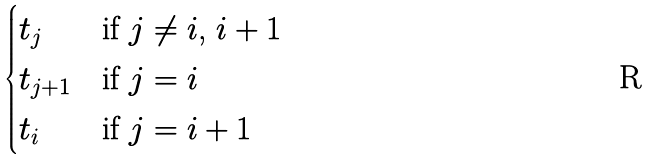Convert formula to latex. <formula><loc_0><loc_0><loc_500><loc_500>\begin{cases} t _ { j } & \text {if $j \ne i$, $i+1$} \\ t _ { j + 1 } & \text {if $j = i$} \\ t _ { i } & \text {if $j = i+1$} \end{cases}</formula> 